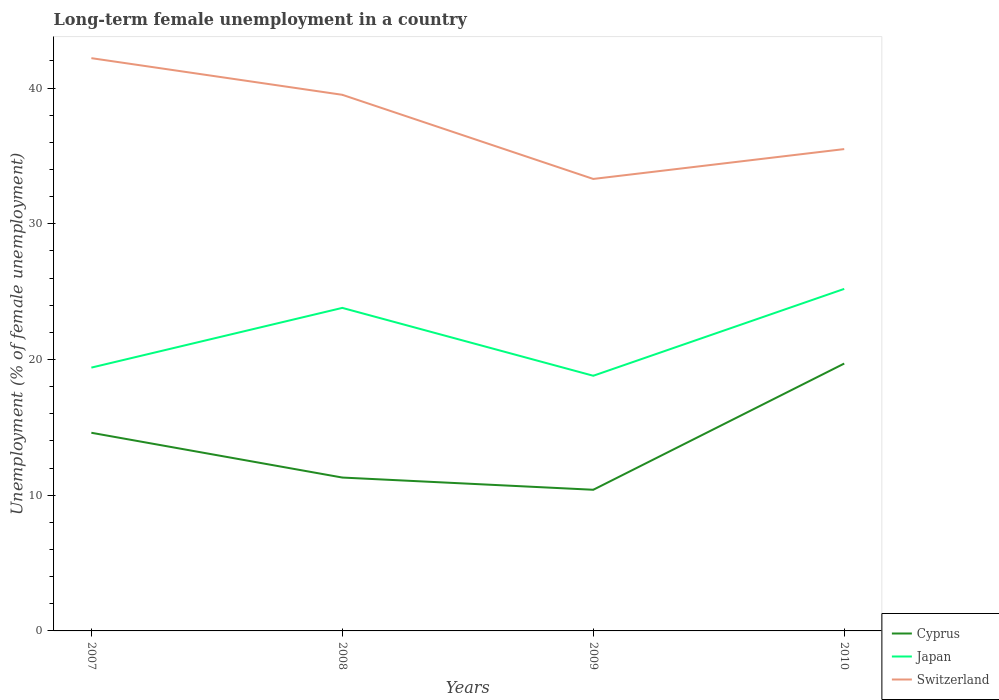Does the line corresponding to Switzerland intersect with the line corresponding to Japan?
Make the answer very short. No. Across all years, what is the maximum percentage of long-term unemployed female population in Cyprus?
Provide a succinct answer. 10.4. What is the total percentage of long-term unemployed female population in Switzerland in the graph?
Your answer should be very brief. 6.7. What is the difference between the highest and the second highest percentage of long-term unemployed female population in Japan?
Give a very brief answer. 6.4. How many lines are there?
Provide a succinct answer. 3. How many years are there in the graph?
Keep it short and to the point. 4. Are the values on the major ticks of Y-axis written in scientific E-notation?
Your response must be concise. No. How many legend labels are there?
Provide a succinct answer. 3. What is the title of the graph?
Offer a terse response. Long-term female unemployment in a country. What is the label or title of the Y-axis?
Your answer should be compact. Unemployment (% of female unemployment). What is the Unemployment (% of female unemployment) in Cyprus in 2007?
Make the answer very short. 14.6. What is the Unemployment (% of female unemployment) of Japan in 2007?
Keep it short and to the point. 19.4. What is the Unemployment (% of female unemployment) of Switzerland in 2007?
Offer a very short reply. 42.2. What is the Unemployment (% of female unemployment) in Cyprus in 2008?
Ensure brevity in your answer.  11.3. What is the Unemployment (% of female unemployment) in Japan in 2008?
Offer a very short reply. 23.8. What is the Unemployment (% of female unemployment) of Switzerland in 2008?
Keep it short and to the point. 39.5. What is the Unemployment (% of female unemployment) of Cyprus in 2009?
Ensure brevity in your answer.  10.4. What is the Unemployment (% of female unemployment) of Japan in 2009?
Keep it short and to the point. 18.8. What is the Unemployment (% of female unemployment) of Switzerland in 2009?
Provide a short and direct response. 33.3. What is the Unemployment (% of female unemployment) in Cyprus in 2010?
Keep it short and to the point. 19.7. What is the Unemployment (% of female unemployment) in Japan in 2010?
Ensure brevity in your answer.  25.2. What is the Unemployment (% of female unemployment) in Switzerland in 2010?
Offer a terse response. 35.5. Across all years, what is the maximum Unemployment (% of female unemployment) of Cyprus?
Your answer should be compact. 19.7. Across all years, what is the maximum Unemployment (% of female unemployment) in Japan?
Provide a succinct answer. 25.2. Across all years, what is the maximum Unemployment (% of female unemployment) of Switzerland?
Provide a short and direct response. 42.2. Across all years, what is the minimum Unemployment (% of female unemployment) in Cyprus?
Ensure brevity in your answer.  10.4. Across all years, what is the minimum Unemployment (% of female unemployment) in Japan?
Your answer should be compact. 18.8. Across all years, what is the minimum Unemployment (% of female unemployment) of Switzerland?
Provide a short and direct response. 33.3. What is the total Unemployment (% of female unemployment) in Cyprus in the graph?
Offer a terse response. 56. What is the total Unemployment (% of female unemployment) of Japan in the graph?
Give a very brief answer. 87.2. What is the total Unemployment (% of female unemployment) of Switzerland in the graph?
Your answer should be very brief. 150.5. What is the difference between the Unemployment (% of female unemployment) in Switzerland in 2007 and that in 2008?
Provide a succinct answer. 2.7. What is the difference between the Unemployment (% of female unemployment) of Cyprus in 2007 and that in 2009?
Your response must be concise. 4.2. What is the difference between the Unemployment (% of female unemployment) in Switzerland in 2007 and that in 2009?
Offer a terse response. 8.9. What is the difference between the Unemployment (% of female unemployment) in Japan in 2007 and that in 2010?
Make the answer very short. -5.8. What is the difference between the Unemployment (% of female unemployment) in Switzerland in 2007 and that in 2010?
Provide a succinct answer. 6.7. What is the difference between the Unemployment (% of female unemployment) of Japan in 2008 and that in 2009?
Offer a terse response. 5. What is the difference between the Unemployment (% of female unemployment) of Cyprus in 2008 and that in 2010?
Offer a very short reply. -8.4. What is the difference between the Unemployment (% of female unemployment) of Japan in 2009 and that in 2010?
Ensure brevity in your answer.  -6.4. What is the difference between the Unemployment (% of female unemployment) in Cyprus in 2007 and the Unemployment (% of female unemployment) in Switzerland in 2008?
Ensure brevity in your answer.  -24.9. What is the difference between the Unemployment (% of female unemployment) of Japan in 2007 and the Unemployment (% of female unemployment) of Switzerland in 2008?
Provide a short and direct response. -20.1. What is the difference between the Unemployment (% of female unemployment) of Cyprus in 2007 and the Unemployment (% of female unemployment) of Japan in 2009?
Make the answer very short. -4.2. What is the difference between the Unemployment (% of female unemployment) in Cyprus in 2007 and the Unemployment (% of female unemployment) in Switzerland in 2009?
Your answer should be very brief. -18.7. What is the difference between the Unemployment (% of female unemployment) in Japan in 2007 and the Unemployment (% of female unemployment) in Switzerland in 2009?
Offer a terse response. -13.9. What is the difference between the Unemployment (% of female unemployment) of Cyprus in 2007 and the Unemployment (% of female unemployment) of Japan in 2010?
Make the answer very short. -10.6. What is the difference between the Unemployment (% of female unemployment) in Cyprus in 2007 and the Unemployment (% of female unemployment) in Switzerland in 2010?
Your answer should be very brief. -20.9. What is the difference between the Unemployment (% of female unemployment) in Japan in 2007 and the Unemployment (% of female unemployment) in Switzerland in 2010?
Provide a succinct answer. -16.1. What is the difference between the Unemployment (% of female unemployment) in Cyprus in 2008 and the Unemployment (% of female unemployment) in Japan in 2009?
Offer a terse response. -7.5. What is the difference between the Unemployment (% of female unemployment) of Cyprus in 2008 and the Unemployment (% of female unemployment) of Switzerland in 2009?
Offer a terse response. -22. What is the difference between the Unemployment (% of female unemployment) of Cyprus in 2008 and the Unemployment (% of female unemployment) of Switzerland in 2010?
Give a very brief answer. -24.2. What is the difference between the Unemployment (% of female unemployment) in Cyprus in 2009 and the Unemployment (% of female unemployment) in Japan in 2010?
Offer a very short reply. -14.8. What is the difference between the Unemployment (% of female unemployment) in Cyprus in 2009 and the Unemployment (% of female unemployment) in Switzerland in 2010?
Your answer should be very brief. -25.1. What is the difference between the Unemployment (% of female unemployment) in Japan in 2009 and the Unemployment (% of female unemployment) in Switzerland in 2010?
Offer a terse response. -16.7. What is the average Unemployment (% of female unemployment) in Cyprus per year?
Keep it short and to the point. 14. What is the average Unemployment (% of female unemployment) in Japan per year?
Provide a succinct answer. 21.8. What is the average Unemployment (% of female unemployment) in Switzerland per year?
Your answer should be compact. 37.62. In the year 2007, what is the difference between the Unemployment (% of female unemployment) of Cyprus and Unemployment (% of female unemployment) of Switzerland?
Offer a very short reply. -27.6. In the year 2007, what is the difference between the Unemployment (% of female unemployment) of Japan and Unemployment (% of female unemployment) of Switzerland?
Your response must be concise. -22.8. In the year 2008, what is the difference between the Unemployment (% of female unemployment) in Cyprus and Unemployment (% of female unemployment) in Japan?
Give a very brief answer. -12.5. In the year 2008, what is the difference between the Unemployment (% of female unemployment) in Cyprus and Unemployment (% of female unemployment) in Switzerland?
Provide a short and direct response. -28.2. In the year 2008, what is the difference between the Unemployment (% of female unemployment) in Japan and Unemployment (% of female unemployment) in Switzerland?
Offer a very short reply. -15.7. In the year 2009, what is the difference between the Unemployment (% of female unemployment) of Cyprus and Unemployment (% of female unemployment) of Japan?
Provide a short and direct response. -8.4. In the year 2009, what is the difference between the Unemployment (% of female unemployment) in Cyprus and Unemployment (% of female unemployment) in Switzerland?
Offer a terse response. -22.9. In the year 2009, what is the difference between the Unemployment (% of female unemployment) of Japan and Unemployment (% of female unemployment) of Switzerland?
Provide a short and direct response. -14.5. In the year 2010, what is the difference between the Unemployment (% of female unemployment) of Cyprus and Unemployment (% of female unemployment) of Japan?
Give a very brief answer. -5.5. In the year 2010, what is the difference between the Unemployment (% of female unemployment) in Cyprus and Unemployment (% of female unemployment) in Switzerland?
Your answer should be very brief. -15.8. In the year 2010, what is the difference between the Unemployment (% of female unemployment) of Japan and Unemployment (% of female unemployment) of Switzerland?
Make the answer very short. -10.3. What is the ratio of the Unemployment (% of female unemployment) in Cyprus in 2007 to that in 2008?
Your answer should be very brief. 1.29. What is the ratio of the Unemployment (% of female unemployment) of Japan in 2007 to that in 2008?
Your response must be concise. 0.82. What is the ratio of the Unemployment (% of female unemployment) in Switzerland in 2007 to that in 2008?
Make the answer very short. 1.07. What is the ratio of the Unemployment (% of female unemployment) of Cyprus in 2007 to that in 2009?
Provide a succinct answer. 1.4. What is the ratio of the Unemployment (% of female unemployment) of Japan in 2007 to that in 2009?
Your answer should be very brief. 1.03. What is the ratio of the Unemployment (% of female unemployment) in Switzerland in 2007 to that in 2009?
Ensure brevity in your answer.  1.27. What is the ratio of the Unemployment (% of female unemployment) of Cyprus in 2007 to that in 2010?
Keep it short and to the point. 0.74. What is the ratio of the Unemployment (% of female unemployment) in Japan in 2007 to that in 2010?
Your answer should be very brief. 0.77. What is the ratio of the Unemployment (% of female unemployment) in Switzerland in 2007 to that in 2010?
Provide a short and direct response. 1.19. What is the ratio of the Unemployment (% of female unemployment) of Cyprus in 2008 to that in 2009?
Offer a terse response. 1.09. What is the ratio of the Unemployment (% of female unemployment) of Japan in 2008 to that in 2009?
Provide a short and direct response. 1.27. What is the ratio of the Unemployment (% of female unemployment) in Switzerland in 2008 to that in 2009?
Provide a succinct answer. 1.19. What is the ratio of the Unemployment (% of female unemployment) of Cyprus in 2008 to that in 2010?
Your answer should be compact. 0.57. What is the ratio of the Unemployment (% of female unemployment) in Japan in 2008 to that in 2010?
Make the answer very short. 0.94. What is the ratio of the Unemployment (% of female unemployment) of Switzerland in 2008 to that in 2010?
Your response must be concise. 1.11. What is the ratio of the Unemployment (% of female unemployment) of Cyprus in 2009 to that in 2010?
Offer a very short reply. 0.53. What is the ratio of the Unemployment (% of female unemployment) in Japan in 2009 to that in 2010?
Your response must be concise. 0.75. What is the ratio of the Unemployment (% of female unemployment) of Switzerland in 2009 to that in 2010?
Offer a terse response. 0.94. What is the difference between the highest and the second highest Unemployment (% of female unemployment) of Switzerland?
Your response must be concise. 2.7. What is the difference between the highest and the lowest Unemployment (% of female unemployment) in Cyprus?
Provide a succinct answer. 9.3. What is the difference between the highest and the lowest Unemployment (% of female unemployment) in Japan?
Keep it short and to the point. 6.4. What is the difference between the highest and the lowest Unemployment (% of female unemployment) in Switzerland?
Keep it short and to the point. 8.9. 